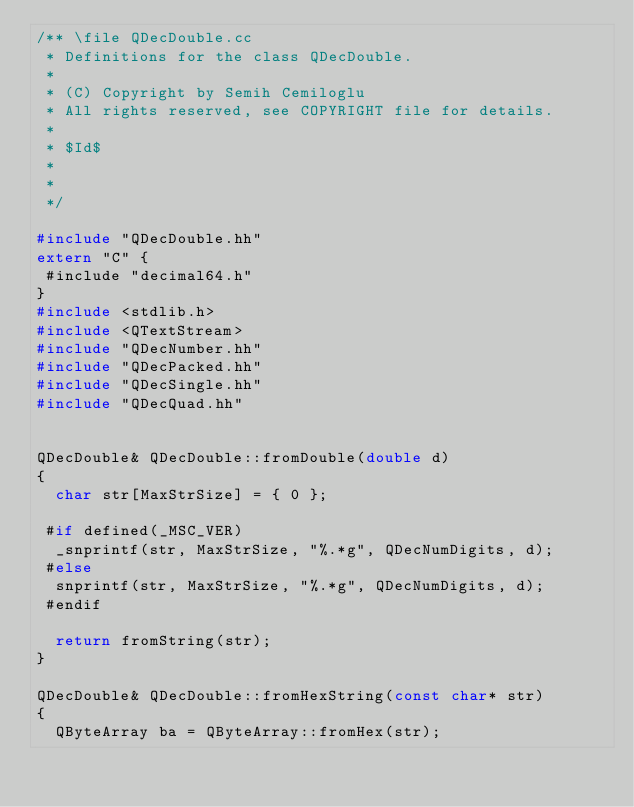<code> <loc_0><loc_0><loc_500><loc_500><_C++_>/** \file QDecDouble.cc
 * Definitions for the class QDecDouble.
 *
 * (C) Copyright by Semih Cemiloglu
 * All rights reserved, see COPYRIGHT file for details.
 *
 * $Id$
 *
 *
 */

#include "QDecDouble.hh"
extern "C" {
 #include "decimal64.h"
}
#include <stdlib.h>
#include <QTextStream>
#include "QDecNumber.hh"
#include "QDecPacked.hh"
#include "QDecSingle.hh"
#include "QDecQuad.hh"


QDecDouble& QDecDouble::fromDouble(double d)
{
  char str[MaxStrSize] = { 0 };

 #if defined(_MSC_VER)
  _snprintf(str, MaxStrSize, "%.*g", QDecNumDigits, d);
 #else
  snprintf(str, MaxStrSize, "%.*g", QDecNumDigits, d);
 #endif

  return fromString(str);
}

QDecDouble& QDecDouble::fromHexString(const char* str)
{
  QByteArray ba = QByteArray::fromHex(str);</code> 